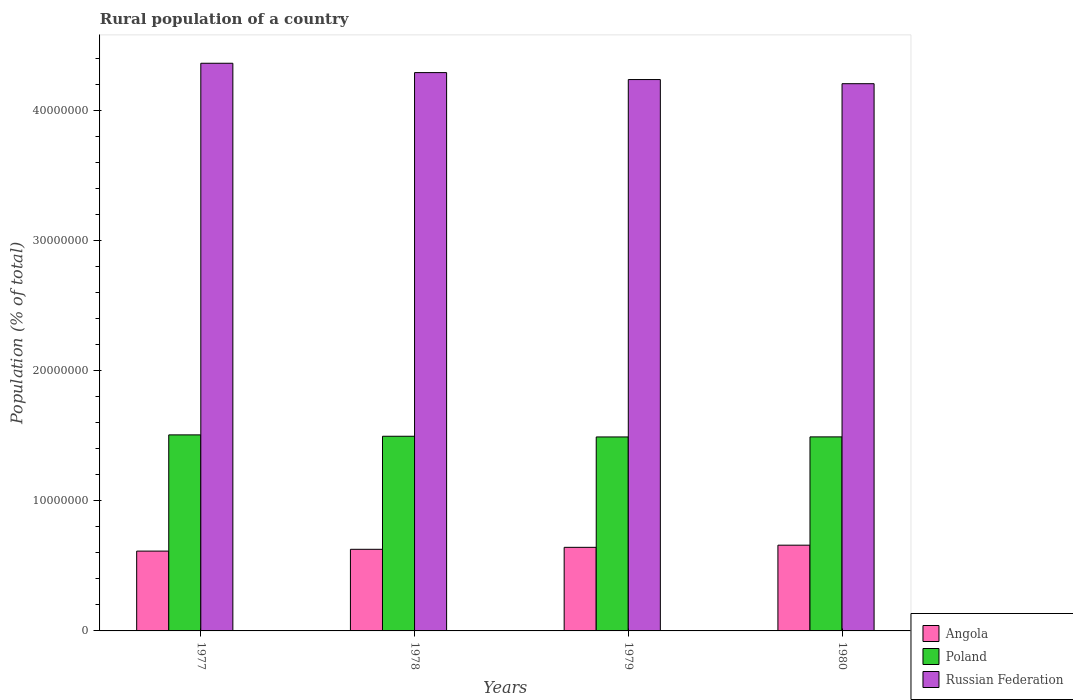How many different coloured bars are there?
Offer a terse response. 3. What is the label of the 3rd group of bars from the left?
Your response must be concise. 1979. In how many cases, is the number of bars for a given year not equal to the number of legend labels?
Your response must be concise. 0. What is the rural population in Angola in 1977?
Provide a short and direct response. 6.13e+06. Across all years, what is the maximum rural population in Angola?
Your response must be concise. 6.59e+06. Across all years, what is the minimum rural population in Poland?
Provide a short and direct response. 1.49e+07. What is the total rural population in Poland in the graph?
Offer a very short reply. 5.98e+07. What is the difference between the rural population in Angola in 1978 and that in 1979?
Your answer should be very brief. -1.51e+05. What is the difference between the rural population in Russian Federation in 1978 and the rural population in Poland in 1979?
Your answer should be compact. 2.80e+07. What is the average rural population in Poland per year?
Your answer should be very brief. 1.50e+07. In the year 1980, what is the difference between the rural population in Russian Federation and rural population in Angola?
Offer a very short reply. 3.55e+07. What is the ratio of the rural population in Angola in 1978 to that in 1980?
Offer a very short reply. 0.95. Is the rural population in Poland in 1978 less than that in 1980?
Provide a short and direct response. No. What is the difference between the highest and the second highest rural population in Angola?
Your response must be concise. 1.66e+05. What is the difference between the highest and the lowest rural population in Russian Federation?
Your response must be concise. 1.57e+06. In how many years, is the rural population in Russian Federation greater than the average rural population in Russian Federation taken over all years?
Provide a short and direct response. 2. Is the sum of the rural population in Angola in 1977 and 1980 greater than the maximum rural population in Poland across all years?
Offer a terse response. No. What does the 1st bar from the left in 1980 represents?
Offer a terse response. Angola. Is it the case that in every year, the sum of the rural population in Angola and rural population in Russian Federation is greater than the rural population in Poland?
Offer a terse response. Yes. How many bars are there?
Keep it short and to the point. 12. How many years are there in the graph?
Keep it short and to the point. 4. Are the values on the major ticks of Y-axis written in scientific E-notation?
Your response must be concise. No. Does the graph contain grids?
Make the answer very short. No. Where does the legend appear in the graph?
Your response must be concise. Bottom right. What is the title of the graph?
Make the answer very short. Rural population of a country. What is the label or title of the Y-axis?
Provide a short and direct response. Population (% of total). What is the Population (% of total) of Angola in 1977?
Make the answer very short. 6.13e+06. What is the Population (% of total) in Poland in 1977?
Make the answer very short. 1.51e+07. What is the Population (% of total) in Russian Federation in 1977?
Offer a terse response. 4.36e+07. What is the Population (% of total) of Angola in 1978?
Your answer should be very brief. 6.27e+06. What is the Population (% of total) in Poland in 1978?
Provide a short and direct response. 1.50e+07. What is the Population (% of total) in Russian Federation in 1978?
Your answer should be compact. 4.29e+07. What is the Population (% of total) in Angola in 1979?
Ensure brevity in your answer.  6.42e+06. What is the Population (% of total) of Poland in 1979?
Offer a very short reply. 1.49e+07. What is the Population (% of total) of Russian Federation in 1979?
Ensure brevity in your answer.  4.24e+07. What is the Population (% of total) in Angola in 1980?
Your answer should be very brief. 6.59e+06. What is the Population (% of total) in Poland in 1980?
Offer a very short reply. 1.49e+07. What is the Population (% of total) of Russian Federation in 1980?
Keep it short and to the point. 4.20e+07. Across all years, what is the maximum Population (% of total) in Angola?
Ensure brevity in your answer.  6.59e+06. Across all years, what is the maximum Population (% of total) in Poland?
Give a very brief answer. 1.51e+07. Across all years, what is the maximum Population (% of total) in Russian Federation?
Provide a short and direct response. 4.36e+07. Across all years, what is the minimum Population (% of total) in Angola?
Give a very brief answer. 6.13e+06. Across all years, what is the minimum Population (% of total) of Poland?
Keep it short and to the point. 1.49e+07. Across all years, what is the minimum Population (% of total) in Russian Federation?
Give a very brief answer. 4.20e+07. What is the total Population (% of total) in Angola in the graph?
Your answer should be compact. 2.54e+07. What is the total Population (% of total) of Poland in the graph?
Offer a terse response. 5.98e+07. What is the total Population (% of total) of Russian Federation in the graph?
Make the answer very short. 1.71e+08. What is the difference between the Population (% of total) of Angola in 1977 and that in 1978?
Your answer should be very brief. -1.38e+05. What is the difference between the Population (% of total) of Poland in 1977 and that in 1978?
Keep it short and to the point. 1.05e+05. What is the difference between the Population (% of total) of Russian Federation in 1977 and that in 1978?
Ensure brevity in your answer.  7.18e+05. What is the difference between the Population (% of total) of Angola in 1977 and that in 1979?
Make the answer very short. -2.89e+05. What is the difference between the Population (% of total) in Poland in 1977 and that in 1979?
Offer a very short reply. 1.58e+05. What is the difference between the Population (% of total) of Russian Federation in 1977 and that in 1979?
Keep it short and to the point. 1.25e+06. What is the difference between the Population (% of total) in Angola in 1977 and that in 1980?
Ensure brevity in your answer.  -4.55e+05. What is the difference between the Population (% of total) in Poland in 1977 and that in 1980?
Keep it short and to the point. 1.53e+05. What is the difference between the Population (% of total) of Russian Federation in 1977 and that in 1980?
Provide a succinct answer. 1.57e+06. What is the difference between the Population (% of total) in Angola in 1978 and that in 1979?
Offer a very short reply. -1.51e+05. What is the difference between the Population (% of total) of Poland in 1978 and that in 1979?
Your answer should be compact. 5.29e+04. What is the difference between the Population (% of total) of Russian Federation in 1978 and that in 1979?
Make the answer very short. 5.35e+05. What is the difference between the Population (% of total) in Angola in 1978 and that in 1980?
Make the answer very short. -3.17e+05. What is the difference between the Population (% of total) of Poland in 1978 and that in 1980?
Your response must be concise. 4.77e+04. What is the difference between the Population (% of total) of Russian Federation in 1978 and that in 1980?
Keep it short and to the point. 8.53e+05. What is the difference between the Population (% of total) in Angola in 1979 and that in 1980?
Offer a terse response. -1.66e+05. What is the difference between the Population (% of total) of Poland in 1979 and that in 1980?
Give a very brief answer. -5206. What is the difference between the Population (% of total) in Russian Federation in 1979 and that in 1980?
Offer a very short reply. 3.18e+05. What is the difference between the Population (% of total) of Angola in 1977 and the Population (% of total) of Poland in 1978?
Your answer should be compact. -8.82e+06. What is the difference between the Population (% of total) in Angola in 1977 and the Population (% of total) in Russian Federation in 1978?
Provide a succinct answer. -3.68e+07. What is the difference between the Population (% of total) of Poland in 1977 and the Population (% of total) of Russian Federation in 1978?
Your answer should be compact. -2.78e+07. What is the difference between the Population (% of total) of Angola in 1977 and the Population (% of total) of Poland in 1979?
Your answer should be very brief. -8.77e+06. What is the difference between the Population (% of total) of Angola in 1977 and the Population (% of total) of Russian Federation in 1979?
Keep it short and to the point. -3.62e+07. What is the difference between the Population (% of total) in Poland in 1977 and the Population (% of total) in Russian Federation in 1979?
Offer a terse response. -2.73e+07. What is the difference between the Population (% of total) of Angola in 1977 and the Population (% of total) of Poland in 1980?
Offer a very short reply. -8.78e+06. What is the difference between the Population (% of total) of Angola in 1977 and the Population (% of total) of Russian Federation in 1980?
Ensure brevity in your answer.  -3.59e+07. What is the difference between the Population (% of total) of Poland in 1977 and the Population (% of total) of Russian Federation in 1980?
Your answer should be very brief. -2.70e+07. What is the difference between the Population (% of total) in Angola in 1978 and the Population (% of total) in Poland in 1979?
Make the answer very short. -8.63e+06. What is the difference between the Population (% of total) of Angola in 1978 and the Population (% of total) of Russian Federation in 1979?
Provide a short and direct response. -3.61e+07. What is the difference between the Population (% of total) of Poland in 1978 and the Population (% of total) of Russian Federation in 1979?
Ensure brevity in your answer.  -2.74e+07. What is the difference between the Population (% of total) of Angola in 1978 and the Population (% of total) of Poland in 1980?
Offer a very short reply. -8.64e+06. What is the difference between the Population (% of total) of Angola in 1978 and the Population (% of total) of Russian Federation in 1980?
Provide a succinct answer. -3.58e+07. What is the difference between the Population (% of total) in Poland in 1978 and the Population (% of total) in Russian Federation in 1980?
Ensure brevity in your answer.  -2.71e+07. What is the difference between the Population (% of total) of Angola in 1979 and the Population (% of total) of Poland in 1980?
Make the answer very short. -8.49e+06. What is the difference between the Population (% of total) in Angola in 1979 and the Population (% of total) in Russian Federation in 1980?
Your response must be concise. -3.56e+07. What is the difference between the Population (% of total) of Poland in 1979 and the Population (% of total) of Russian Federation in 1980?
Your answer should be compact. -2.71e+07. What is the average Population (% of total) in Angola per year?
Ensure brevity in your answer.  6.35e+06. What is the average Population (% of total) of Poland per year?
Offer a terse response. 1.50e+07. What is the average Population (% of total) in Russian Federation per year?
Keep it short and to the point. 4.27e+07. In the year 1977, what is the difference between the Population (% of total) of Angola and Population (% of total) of Poland?
Keep it short and to the point. -8.93e+06. In the year 1977, what is the difference between the Population (% of total) of Angola and Population (% of total) of Russian Federation?
Provide a short and direct response. -3.75e+07. In the year 1977, what is the difference between the Population (% of total) of Poland and Population (% of total) of Russian Federation?
Your answer should be compact. -2.86e+07. In the year 1978, what is the difference between the Population (% of total) in Angola and Population (% of total) in Poland?
Your response must be concise. -8.69e+06. In the year 1978, what is the difference between the Population (% of total) in Angola and Population (% of total) in Russian Federation?
Give a very brief answer. -3.66e+07. In the year 1978, what is the difference between the Population (% of total) in Poland and Population (% of total) in Russian Federation?
Offer a very short reply. -2.79e+07. In the year 1979, what is the difference between the Population (% of total) of Angola and Population (% of total) of Poland?
Your response must be concise. -8.48e+06. In the year 1979, what is the difference between the Population (% of total) in Angola and Population (% of total) in Russian Federation?
Your answer should be compact. -3.59e+07. In the year 1979, what is the difference between the Population (% of total) of Poland and Population (% of total) of Russian Federation?
Your answer should be very brief. -2.75e+07. In the year 1980, what is the difference between the Population (% of total) in Angola and Population (% of total) in Poland?
Offer a very short reply. -8.32e+06. In the year 1980, what is the difference between the Population (% of total) of Angola and Population (% of total) of Russian Federation?
Your response must be concise. -3.55e+07. In the year 1980, what is the difference between the Population (% of total) in Poland and Population (% of total) in Russian Federation?
Your answer should be very brief. -2.71e+07. What is the ratio of the Population (% of total) in Angola in 1977 to that in 1978?
Provide a short and direct response. 0.98. What is the ratio of the Population (% of total) of Poland in 1977 to that in 1978?
Offer a terse response. 1.01. What is the ratio of the Population (% of total) in Russian Federation in 1977 to that in 1978?
Offer a terse response. 1.02. What is the ratio of the Population (% of total) in Angola in 1977 to that in 1979?
Offer a terse response. 0.96. What is the ratio of the Population (% of total) in Poland in 1977 to that in 1979?
Offer a terse response. 1.01. What is the ratio of the Population (% of total) of Russian Federation in 1977 to that in 1979?
Make the answer very short. 1.03. What is the ratio of the Population (% of total) in Poland in 1977 to that in 1980?
Make the answer very short. 1.01. What is the ratio of the Population (% of total) in Russian Federation in 1977 to that in 1980?
Make the answer very short. 1.04. What is the ratio of the Population (% of total) of Angola in 1978 to that in 1979?
Your answer should be very brief. 0.98. What is the ratio of the Population (% of total) in Russian Federation in 1978 to that in 1979?
Offer a very short reply. 1.01. What is the ratio of the Population (% of total) in Angola in 1978 to that in 1980?
Offer a very short reply. 0.95. What is the ratio of the Population (% of total) in Poland in 1978 to that in 1980?
Your answer should be very brief. 1. What is the ratio of the Population (% of total) in Russian Federation in 1978 to that in 1980?
Keep it short and to the point. 1.02. What is the ratio of the Population (% of total) of Angola in 1979 to that in 1980?
Keep it short and to the point. 0.97. What is the ratio of the Population (% of total) of Russian Federation in 1979 to that in 1980?
Your answer should be very brief. 1.01. What is the difference between the highest and the second highest Population (% of total) in Angola?
Your answer should be very brief. 1.66e+05. What is the difference between the highest and the second highest Population (% of total) of Poland?
Your answer should be compact. 1.05e+05. What is the difference between the highest and the second highest Population (% of total) of Russian Federation?
Ensure brevity in your answer.  7.18e+05. What is the difference between the highest and the lowest Population (% of total) of Angola?
Keep it short and to the point. 4.55e+05. What is the difference between the highest and the lowest Population (% of total) of Poland?
Your response must be concise. 1.58e+05. What is the difference between the highest and the lowest Population (% of total) in Russian Federation?
Offer a very short reply. 1.57e+06. 